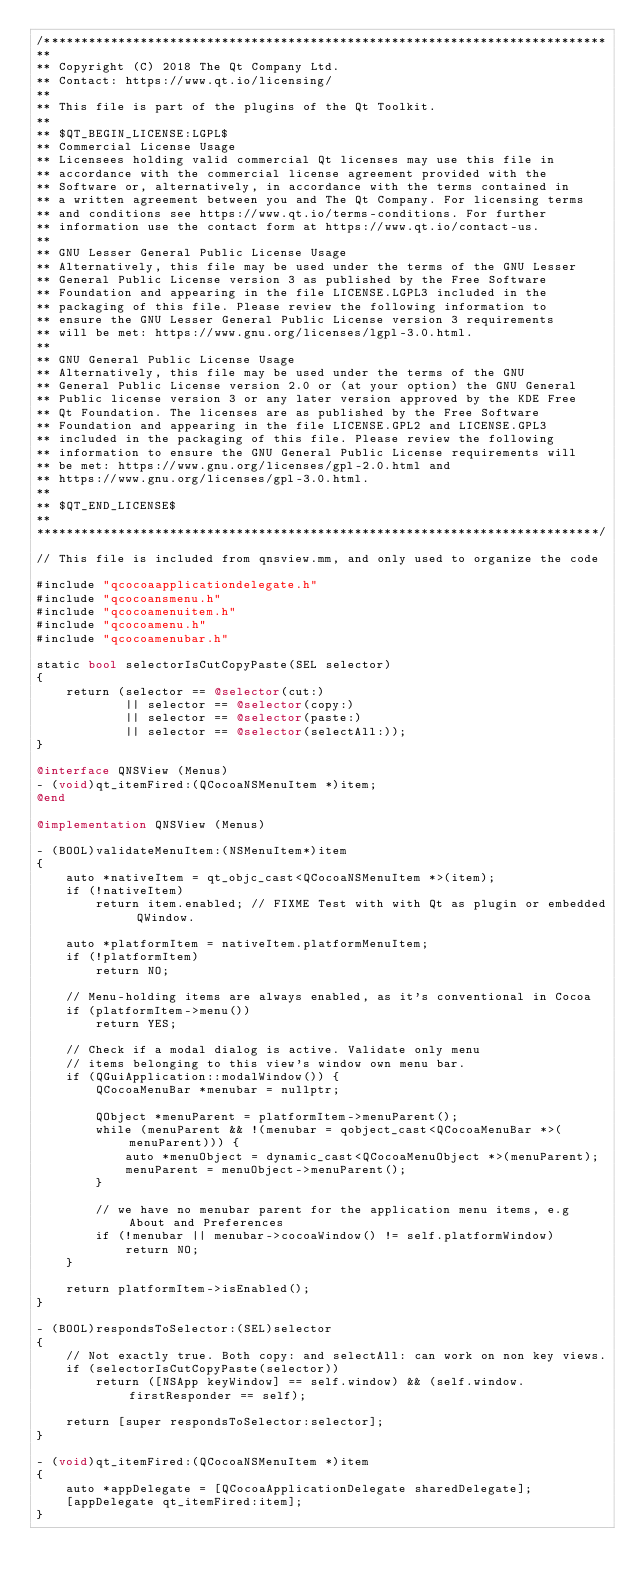Convert code to text. <code><loc_0><loc_0><loc_500><loc_500><_ObjectiveC_>/****************************************************************************
**
** Copyright (C) 2018 The Qt Company Ltd.
** Contact: https://www.qt.io/licensing/
**
** This file is part of the plugins of the Qt Toolkit.
**
** $QT_BEGIN_LICENSE:LGPL$
** Commercial License Usage
** Licensees holding valid commercial Qt licenses may use this file in
** accordance with the commercial license agreement provided with the
** Software or, alternatively, in accordance with the terms contained in
** a written agreement between you and The Qt Company. For licensing terms
** and conditions see https://www.qt.io/terms-conditions. For further
** information use the contact form at https://www.qt.io/contact-us.
**
** GNU Lesser General Public License Usage
** Alternatively, this file may be used under the terms of the GNU Lesser
** General Public License version 3 as published by the Free Software
** Foundation and appearing in the file LICENSE.LGPL3 included in the
** packaging of this file. Please review the following information to
** ensure the GNU Lesser General Public License version 3 requirements
** will be met: https://www.gnu.org/licenses/lgpl-3.0.html.
**
** GNU General Public License Usage
** Alternatively, this file may be used under the terms of the GNU
** General Public License version 2.0 or (at your option) the GNU General
** Public license version 3 or any later version approved by the KDE Free
** Qt Foundation. The licenses are as published by the Free Software
** Foundation and appearing in the file LICENSE.GPL2 and LICENSE.GPL3
** included in the packaging of this file. Please review the following
** information to ensure the GNU General Public License requirements will
** be met: https://www.gnu.org/licenses/gpl-2.0.html and
** https://www.gnu.org/licenses/gpl-3.0.html.
**
** $QT_END_LICENSE$
**
****************************************************************************/

// This file is included from qnsview.mm, and only used to organize the code

#include "qcocoaapplicationdelegate.h"
#include "qcocoansmenu.h"
#include "qcocoamenuitem.h"
#include "qcocoamenu.h"
#include "qcocoamenubar.h"

static bool selectorIsCutCopyPaste(SEL selector)
{
    return (selector == @selector(cut:)
            || selector == @selector(copy:)
            || selector == @selector(paste:)
            || selector == @selector(selectAll:));
}

@interface QNSView (Menus)
- (void)qt_itemFired:(QCocoaNSMenuItem *)item;
@end

@implementation QNSView (Menus)

- (BOOL)validateMenuItem:(NSMenuItem*)item
{
    auto *nativeItem = qt_objc_cast<QCocoaNSMenuItem *>(item);
    if (!nativeItem)
        return item.enabled; // FIXME Test with with Qt as plugin or embedded QWindow.

    auto *platformItem = nativeItem.platformMenuItem;
    if (!platformItem)
        return NO;

    // Menu-holding items are always enabled, as it's conventional in Cocoa
    if (platformItem->menu())
        return YES;

    // Check if a modal dialog is active. Validate only menu
    // items belonging to this view's window own menu bar.
    if (QGuiApplication::modalWindow()) {
        QCocoaMenuBar *menubar = nullptr;

        QObject *menuParent = platformItem->menuParent();
        while (menuParent && !(menubar = qobject_cast<QCocoaMenuBar *>(menuParent))) {
            auto *menuObject = dynamic_cast<QCocoaMenuObject *>(menuParent);
            menuParent = menuObject->menuParent();
        }

        // we have no menubar parent for the application menu items, e.g About and Preferences
        if (!menubar || menubar->cocoaWindow() != self.platformWindow)
            return NO;
    }

    return platformItem->isEnabled();
}

- (BOOL)respondsToSelector:(SEL)selector
{
    // Not exactly true. Both copy: and selectAll: can work on non key views.
    if (selectorIsCutCopyPaste(selector))
        return ([NSApp keyWindow] == self.window) && (self.window.firstResponder == self);

    return [super respondsToSelector:selector];
}

- (void)qt_itemFired:(QCocoaNSMenuItem *)item
{
    auto *appDelegate = [QCocoaApplicationDelegate sharedDelegate];
    [appDelegate qt_itemFired:item];
}
</code> 